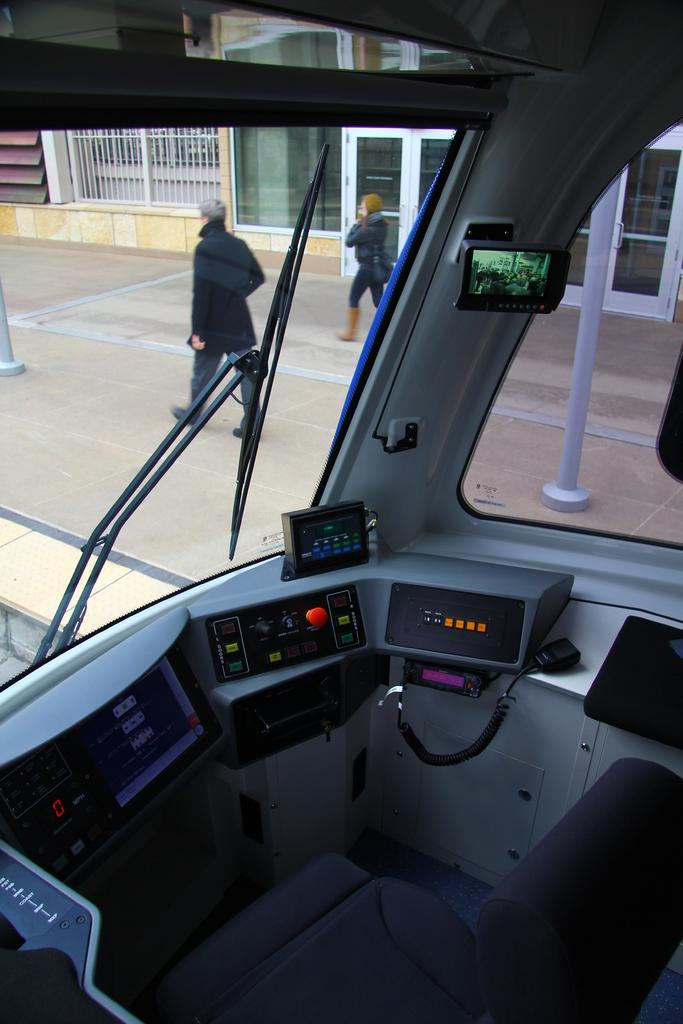What is the setting of the image? The image shows the inside view of a vehicle. How many people are present in the image? There are two persons standing in the vehicle. What can be seen in the background of the image? There is a building visible in the background of the image. What type of pie is being served to the persons in the vehicle? There is no pie present in the image; it shows the inside view of a vehicle with two persons standing in it. 